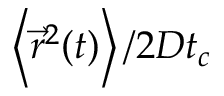<formula> <loc_0><loc_0><loc_500><loc_500>\left \langle \vec { r } ^ { 2 } ( t ) \right \rangle / 2 D t _ { c }</formula> 